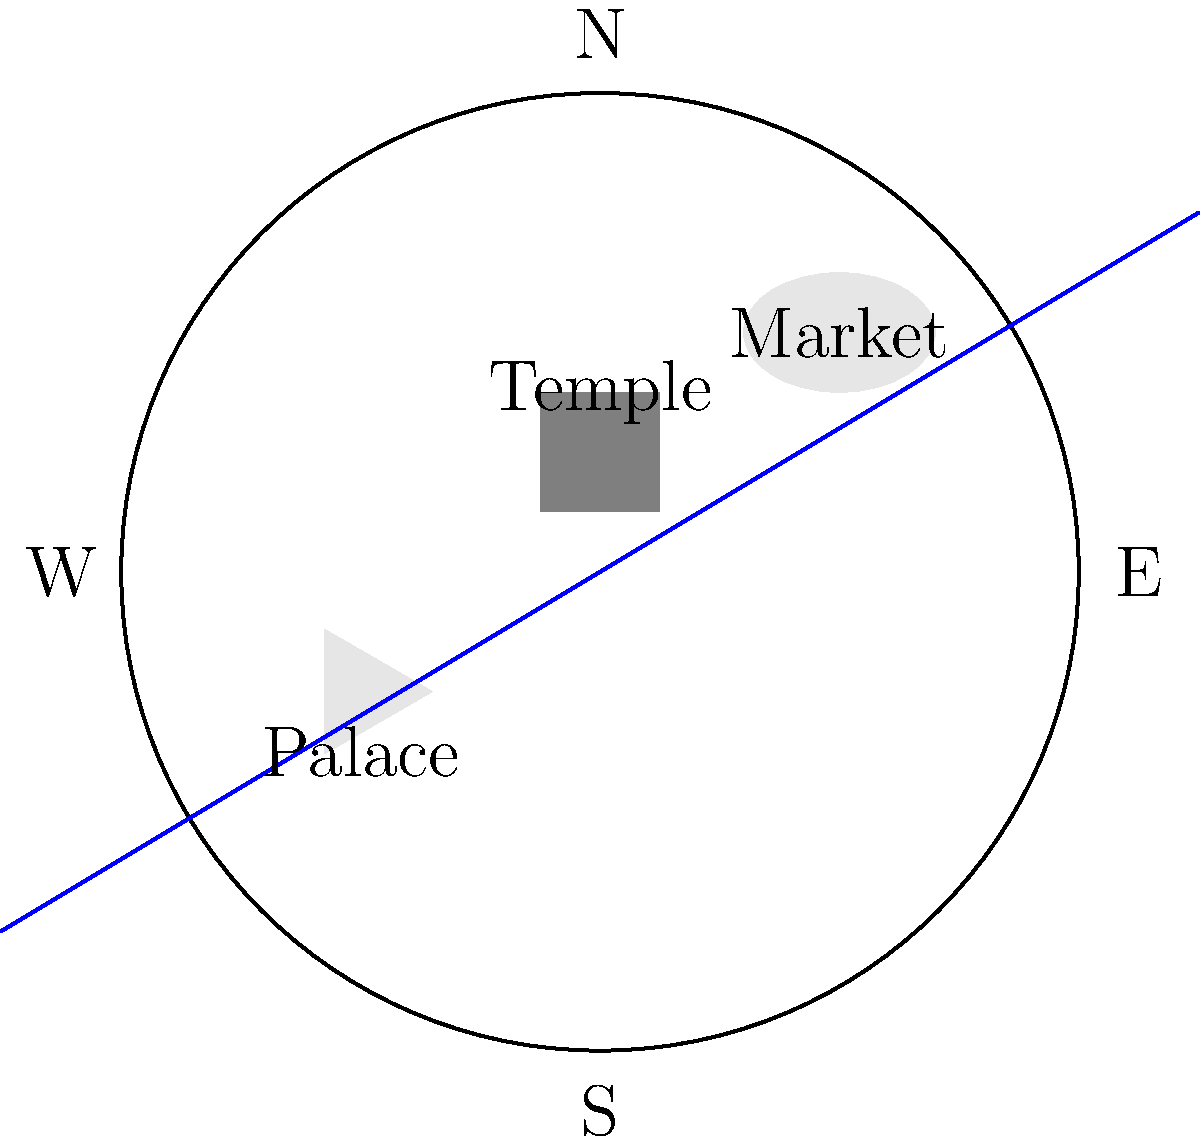Analyze the layout of this ancient city plan. What cultural significance can be inferred from the orientation of the temple in relation to other structures and cardinal directions? To analyze the cultural significance of the temple's orientation in this ancient city plan, we need to consider several factors:

1. Cardinal Directions: The city is oriented with cardinal directions marked (N, E, S, W).

2. Temple Position: The temple is located in the center of the city, suggesting its importance in the society.

3. Temple Orientation: The temple is a square structure with its corners aligned to the cardinal directions, rather than its sides.

4. Other Structures:
   - The palace is located to the southwest of the temple.
   - The market is in the northeast quadrant of the city.

5. Natural Features: A river runs from southwest to northeast through the city.

Cultural Significance:
1. Central importance of religion: The temple's central location indicates the society's focus on religious or spiritual practices.

2. Cosmic alignment: The temple's orientation with its corners pointing to cardinal directions suggests a connection between earthly and celestial realms. This alignment is often found in cultures that emphasize astronomical observations or cosmic symbolism in their religious practices.

3. Hierarchy: The palace's position to the southwest of the temple might indicate a subordinate role of political power to religious authority.

4. Economic planning: The market's location in the northeast, often associated with prosperity in some cultures, could reflect beliefs about auspicious directions for commerce.

5. Natural integration: The river's diagonal flow through the city, aligning somewhat with the temple's orientation, might suggest a harmonious integration of natural and man-made elements in the city planning.

This layout reflects a society where religion plays a central role, with careful attention paid to cosmic alignments and the integration of political, economic, and natural elements within a sacred geography.
Answer: Cosmic alignment and religious centrality 